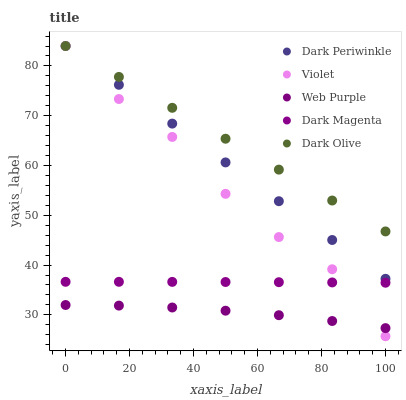Does Web Purple have the minimum area under the curve?
Answer yes or no. Yes. Does Dark Olive have the maximum area under the curve?
Answer yes or no. Yes. Does Dark Periwinkle have the minimum area under the curve?
Answer yes or no. No. Does Dark Periwinkle have the maximum area under the curve?
Answer yes or no. No. Is Dark Periwinkle the smoothest?
Answer yes or no. Yes. Is Violet the roughest?
Answer yes or no. Yes. Is Dark Olive the smoothest?
Answer yes or no. No. Is Dark Olive the roughest?
Answer yes or no. No. Does Violet have the lowest value?
Answer yes or no. Yes. Does Dark Periwinkle have the lowest value?
Answer yes or no. No. Does Violet have the highest value?
Answer yes or no. Yes. Does Dark Magenta have the highest value?
Answer yes or no. No. Is Web Purple less than Dark Olive?
Answer yes or no. Yes. Is Dark Magenta greater than Web Purple?
Answer yes or no. Yes. Does Violet intersect Web Purple?
Answer yes or no. Yes. Is Violet less than Web Purple?
Answer yes or no. No. Is Violet greater than Web Purple?
Answer yes or no. No. Does Web Purple intersect Dark Olive?
Answer yes or no. No. 